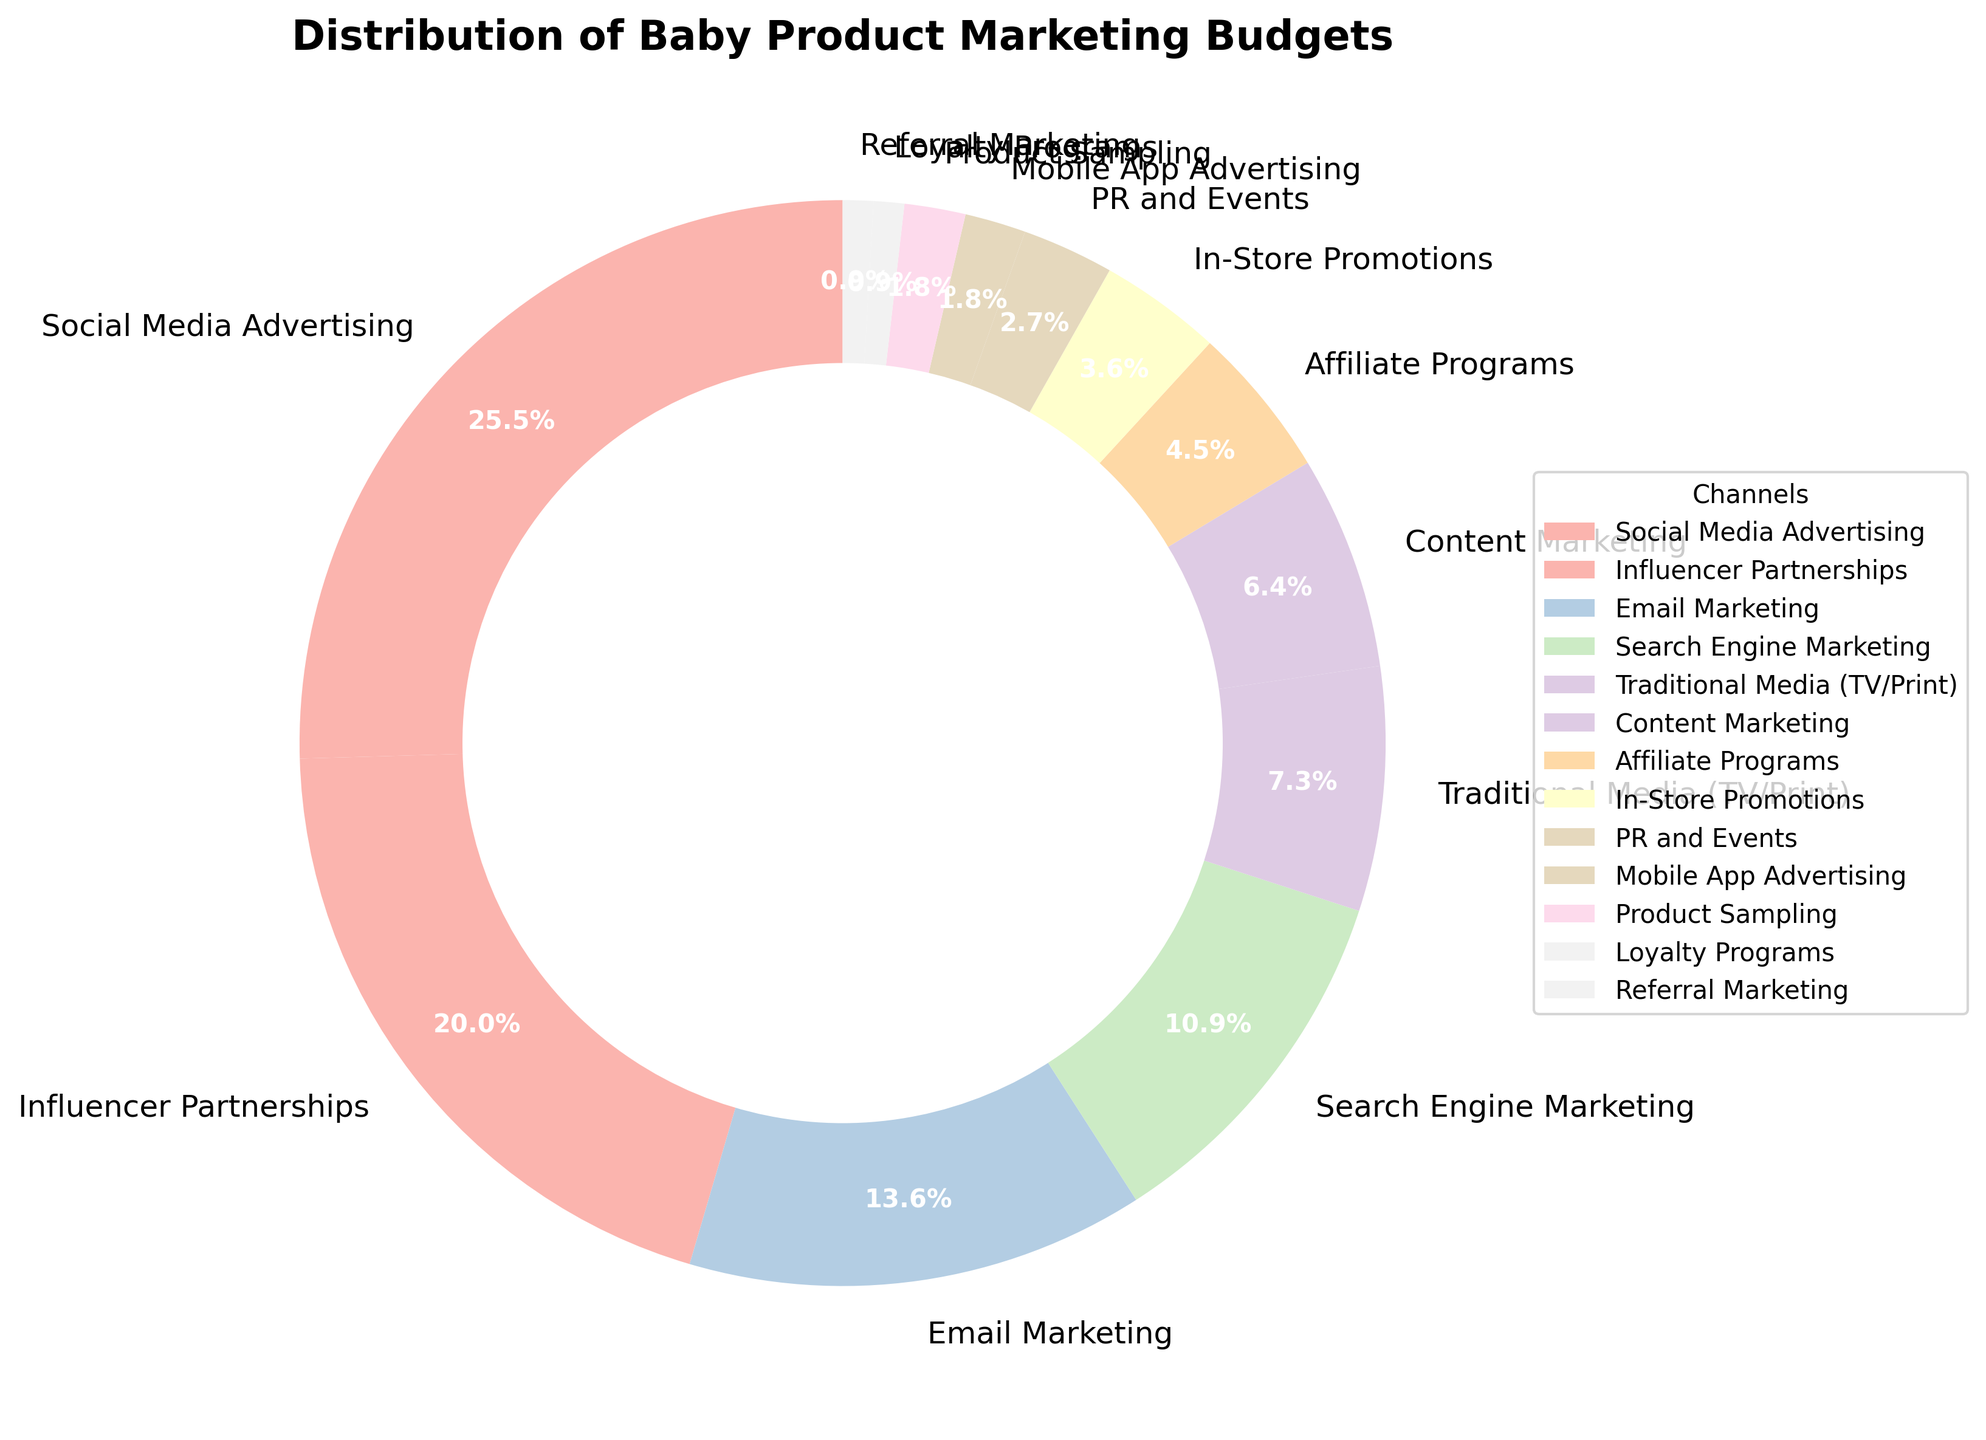Which promotional channel has the highest marketing budget? By observing the size of the wedges in the pie chart, we can identify that the largest wedge represents "Social Media Advertising" with 28%.
Answer: Social Media Advertising How much larger is the budget for Social Media Advertising compared to Product Sampling? The percentage for Social Media Advertising is 28%, and for Product Sampling, it is 2%. The difference can be calculated as 28% - 2% = 26%.
Answer: 26% What is the combined budget percentage for Email Marketing and Search Engine Marketing? The budget for Email Marketing is 15%, and the budget for Search Engine Marketing is 12%. Summing them together, 15% + 12% = 27%.
Answer: 27% Which channel has a smaller budget, PR and Events or Mobile App Advertising? Observing the chart, PR and Events has 3%, and Mobile App Advertising has 2%. Thus, Mobile App Advertising has a smaller budget.
Answer: Mobile App Advertising Are there more channels with a budget equal to or less than 5% than those with a budget greater than 5%? Channels with a budget ≤ 5% include Affiliate Programs, In-Store Promotions, PR and Events, Mobile App Advertising, Product Sampling, Loyalty Programs, and Referral Marketing (7 channels). Channels with a budget > 5% include Social Media Advertising, Influencer Partnerships, Email Marketing, Search Engine Marketing, Traditional Media, and Content Marketing (6 channels). So, there are more channels with a budget ≤ 5%.
Answer: Yes What percentage of the budget is allocated to traditional media forms like TV and Print? The wedge labeled "Traditional Media (TV/Print)" displays a budget percentage of 8%.
Answer: 8% How much smaller is the budget for Loyalty Programs compared to Influencer Partnerships? The percentage for Loyalty Programs is 1%, and for Influencer Partnerships, it is 22%. The difference can be calculated as 22% - 1% = 21%.
Answer: 21% Which promotional channels have a budget equal to 2%? By examining the labels and percentages, we find that both Mobile App Advertising and Product Sampling have a budget of 2%.
Answer: Mobile App Advertising and Product Sampling Is the budget for Content Marketing more than double that of In-Store Promotions? The percentage for Content Marketing is 7%, and for In-Store Promotions, it is 4%. Since 7% is less than double of 4% (which would be 8%), Content Marketing is not more than double.
Answer: No Which budget category appears in the lightest shade in the donut chart? By visually inspecting the fill colors in the chart, the lightest shade corresponds to channels with the smallest percentages, which is likely to be Loyalty Programs or Referral Marketing, both at 1%.
Answer: Loyalty Programs or Referral Marketing 